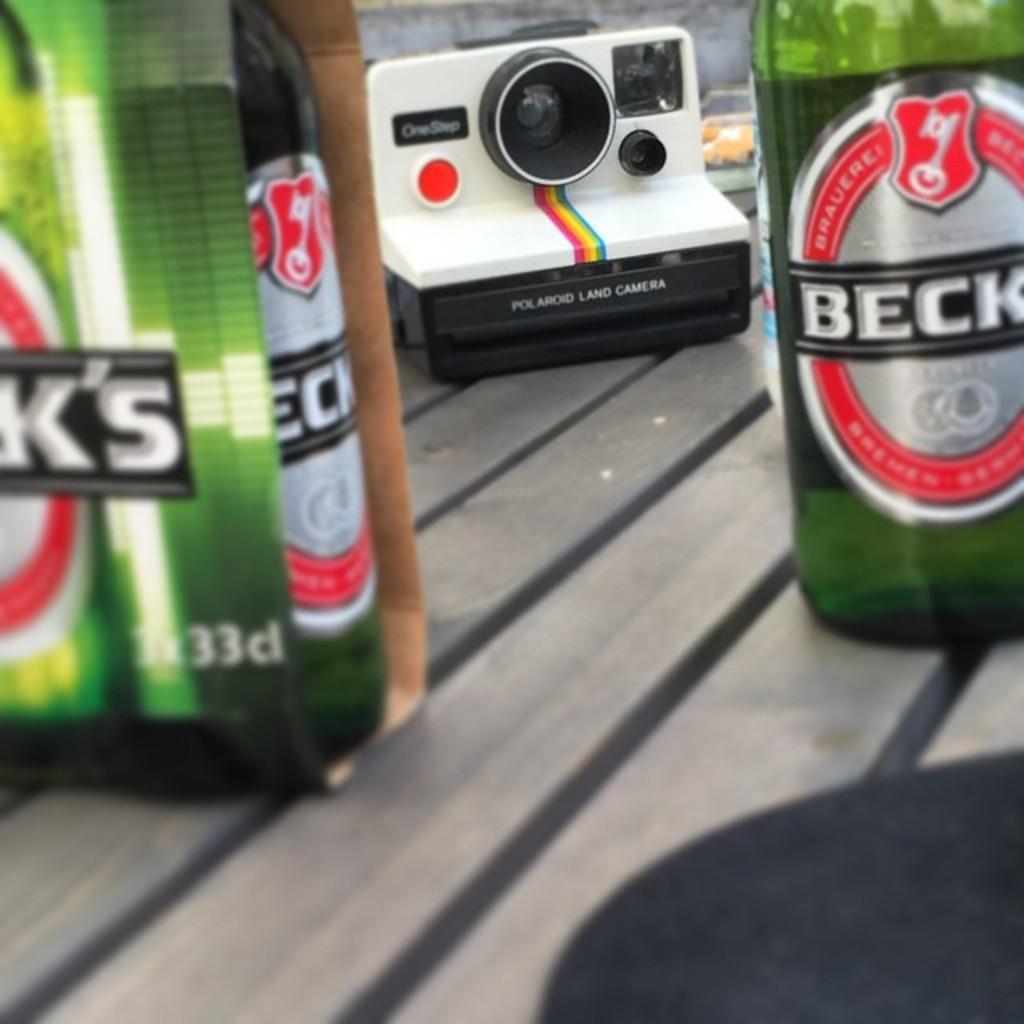Could you give a brief overview of what you see in this image? In this image there are two bottles at the right side and one is at the left side on the bottle we can read beck. In the center there is a camera with red colour button and black colour button which is kept on the table. 